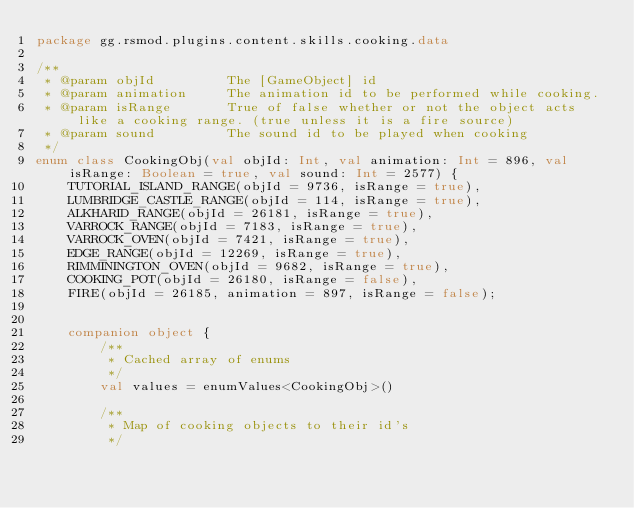Convert code to text. <code><loc_0><loc_0><loc_500><loc_500><_Kotlin_>package gg.rsmod.plugins.content.skills.cooking.data

/**
 * @param objId         The [GameObject] id
 * @param animation     The animation id to be performed while cooking.
 * @param isRange       True of false whether or not the object acts like a cooking range. (true unless it is a fire source)
 * @param sound         The sound id to be played when cooking
 */
enum class CookingObj(val objId: Int, val animation: Int = 896, val isRange: Boolean = true, val sound: Int = 2577) {
    TUTORIAL_ISLAND_RANGE(objId = 9736, isRange = true),
    LUMBRIDGE_CASTLE_RANGE(objId = 114, isRange = true),
    ALKHARID_RANGE(objId = 26181, isRange = true),
    VARROCK_RANGE(objId = 7183, isRange = true),
    VARROCK_OVEN(objId = 7421, isRange = true),
    EDGE_RANGE(objId = 12269, isRange = true),
    RIMMININGTON_OVEN(objId = 9682, isRange = true),
    COOKING_POT(objId = 26180, isRange = false),
    FIRE(objId = 26185, animation = 897, isRange = false);


    companion object {
        /**
         * Cached array of enums
         */
        val values = enumValues<CookingObj>()

        /**
         * Map of cooking objects to their id's
         */</code> 